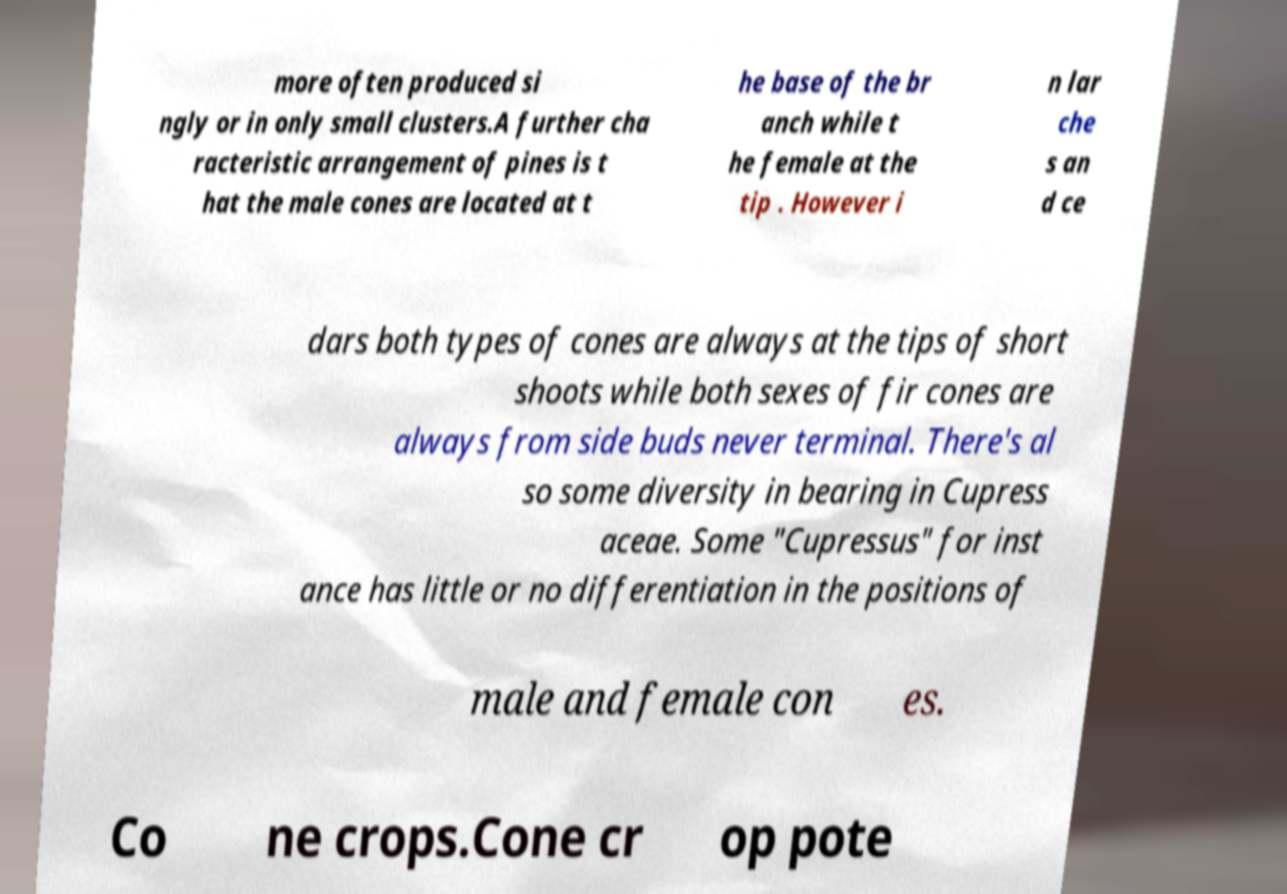What messages or text are displayed in this image? I need them in a readable, typed format. more often produced si ngly or in only small clusters.A further cha racteristic arrangement of pines is t hat the male cones are located at t he base of the br anch while t he female at the tip . However i n lar che s an d ce dars both types of cones are always at the tips of short shoots while both sexes of fir cones are always from side buds never terminal. There's al so some diversity in bearing in Cupress aceae. Some "Cupressus" for inst ance has little or no differentiation in the positions of male and female con es. Co ne crops.Cone cr op pote 